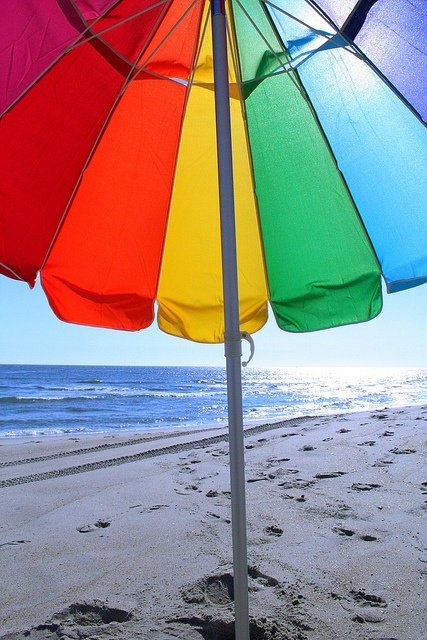Describe the objects in this image and their specific colors. I can see a umbrella in violet, red, brown, green, and gold tones in this image. 